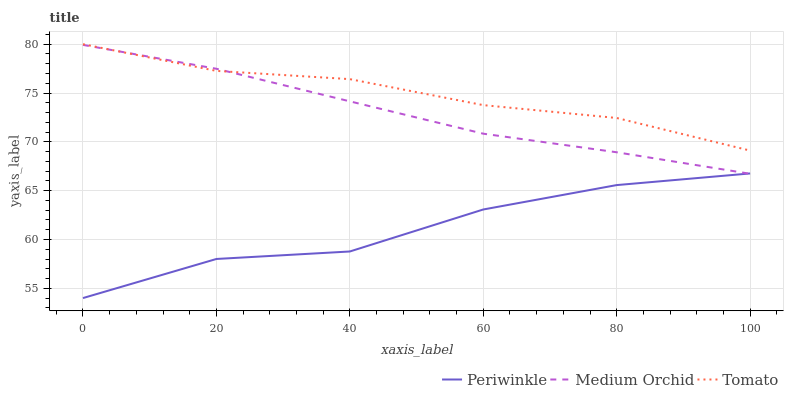Does Periwinkle have the minimum area under the curve?
Answer yes or no. Yes. Does Tomato have the maximum area under the curve?
Answer yes or no. Yes. Does Medium Orchid have the minimum area under the curve?
Answer yes or no. No. Does Medium Orchid have the maximum area under the curve?
Answer yes or no. No. Is Medium Orchid the smoothest?
Answer yes or no. Yes. Is Periwinkle the roughest?
Answer yes or no. Yes. Is Periwinkle the smoothest?
Answer yes or no. No. Is Medium Orchid the roughest?
Answer yes or no. No. Does Periwinkle have the lowest value?
Answer yes or no. Yes. Does Medium Orchid have the lowest value?
Answer yes or no. No. Does Tomato have the highest value?
Answer yes or no. Yes. Does Medium Orchid have the highest value?
Answer yes or no. No. Is Periwinkle less than Tomato?
Answer yes or no. Yes. Is Tomato greater than Periwinkle?
Answer yes or no. Yes. Does Medium Orchid intersect Periwinkle?
Answer yes or no. Yes. Is Medium Orchid less than Periwinkle?
Answer yes or no. No. Is Medium Orchid greater than Periwinkle?
Answer yes or no. No. Does Periwinkle intersect Tomato?
Answer yes or no. No. 